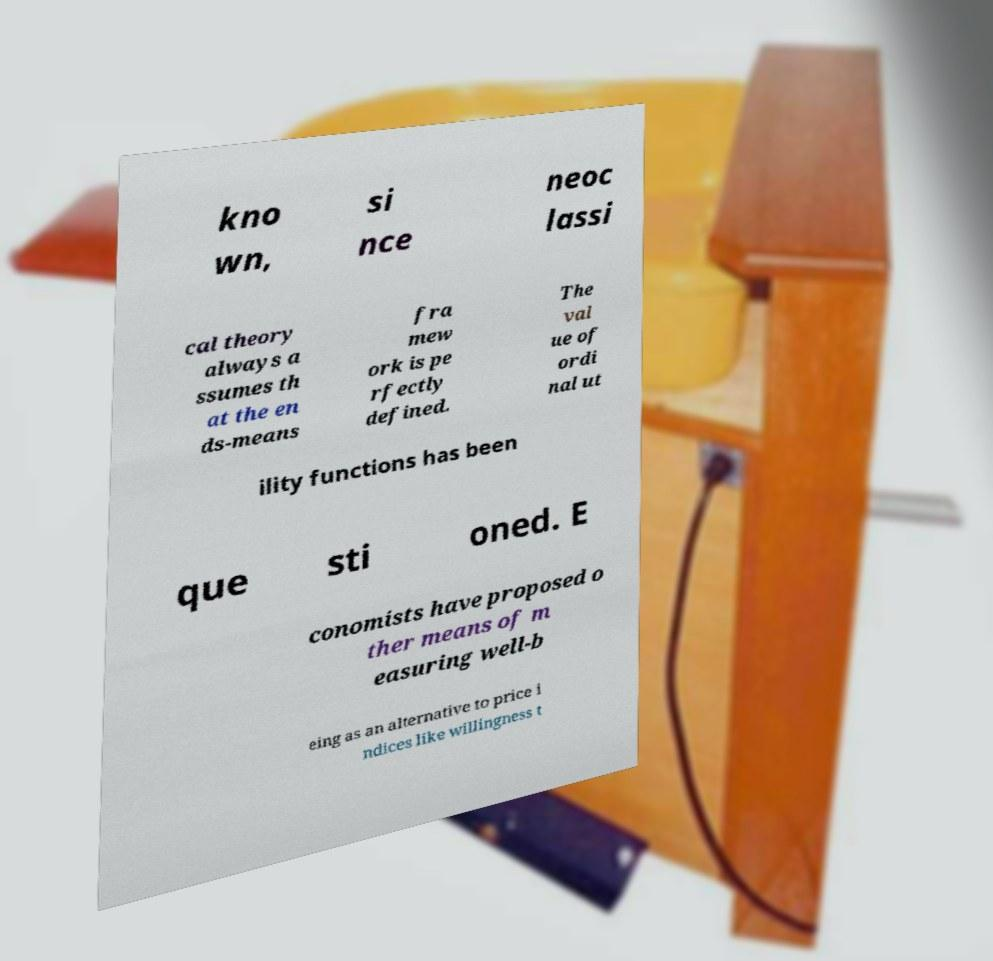Could you extract and type out the text from this image? kno wn, si nce neoc lassi cal theory always a ssumes th at the en ds-means fra mew ork is pe rfectly defined. The val ue of ordi nal ut ility functions has been que sti oned. E conomists have proposed o ther means of m easuring well-b eing as an alternative to price i ndices like willingness t 